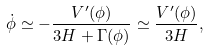<formula> <loc_0><loc_0><loc_500><loc_500>\dot { \phi } \simeq - \frac { V ^ { \prime } ( \phi ) } { 3 H + \Gamma ( \phi ) } \simeq \frac { V ^ { \prime } ( \phi ) } { 3 H } ,</formula> 